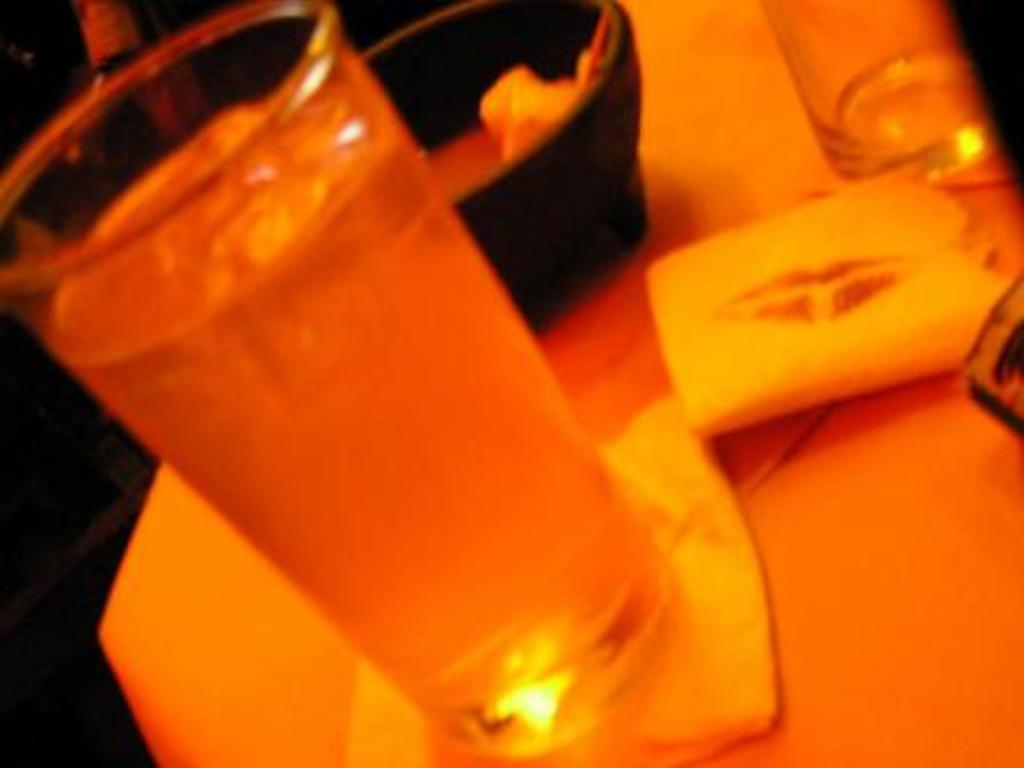What is placed on the surface in the image? There is a bowl and glasses on the surface. What else can be seen on the surface besides the bowl and glasses? There are tissue papers on the surface. Can you describe the contents of one of the glasses? There is a liquid in one of the glasses. What type of weather can be seen in the image? The image does not depict any weather conditions, as it only shows objects on a surface. Can you tell me if the earth is visible in the image? The image does not show the earth; it only shows a bowl, glasses, and tissue papers on a surface. 